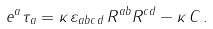Convert formula to latex. <formula><loc_0><loc_0><loc_500><loc_500>e ^ { a } \tau _ { a } = \kappa \, \varepsilon _ { a b c d } \, R ^ { a b } R ^ { c d } - \kappa \, C \, .</formula> 